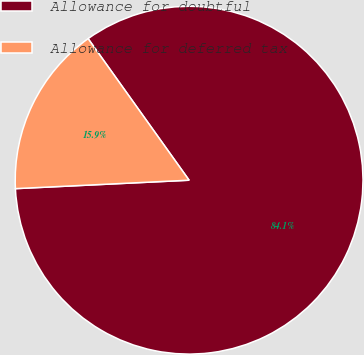<chart> <loc_0><loc_0><loc_500><loc_500><pie_chart><fcel>Allowance for doubtful<fcel>Allowance for deferred tax<nl><fcel>84.09%<fcel>15.91%<nl></chart> 